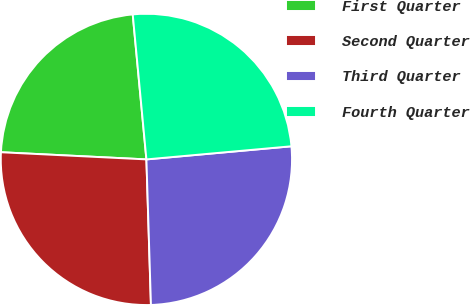Convert chart to OTSL. <chart><loc_0><loc_0><loc_500><loc_500><pie_chart><fcel>First Quarter<fcel>Second Quarter<fcel>Third Quarter<fcel>Fourth Quarter<nl><fcel>22.72%<fcel>26.28%<fcel>25.94%<fcel>25.06%<nl></chart> 